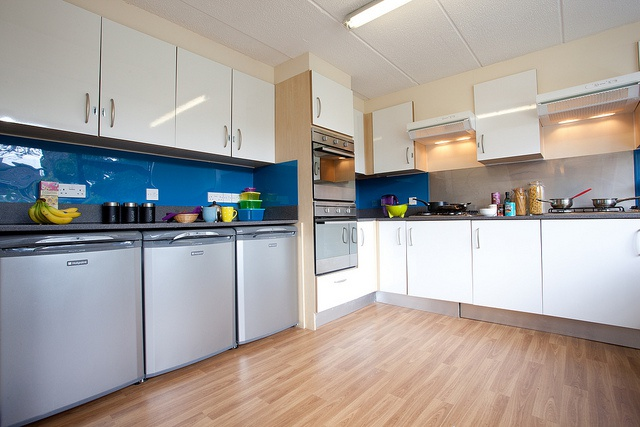Describe the objects in this image and their specific colors. I can see oven in gray, darkgray, and lightgray tones, oven in gray, darkgray, and maroon tones, banana in gray, olive, black, and gold tones, bottle in gray, olive, tan, and maroon tones, and cup in gray, black, navy, and blue tones in this image. 